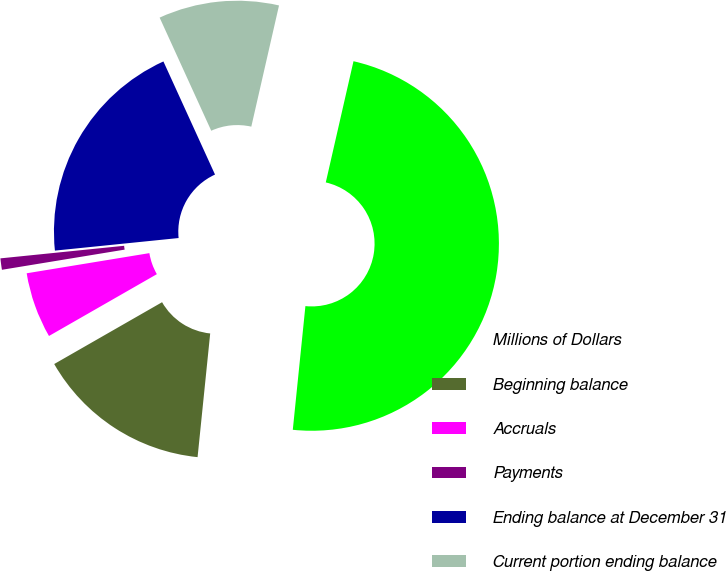<chart> <loc_0><loc_0><loc_500><loc_500><pie_chart><fcel>Millions of Dollars<fcel>Beginning balance<fcel>Accruals<fcel>Payments<fcel>Ending balance at December 31<fcel>Current portion ending balance<nl><fcel>48.04%<fcel>15.1%<fcel>5.69%<fcel>0.98%<fcel>19.8%<fcel>10.39%<nl></chart> 